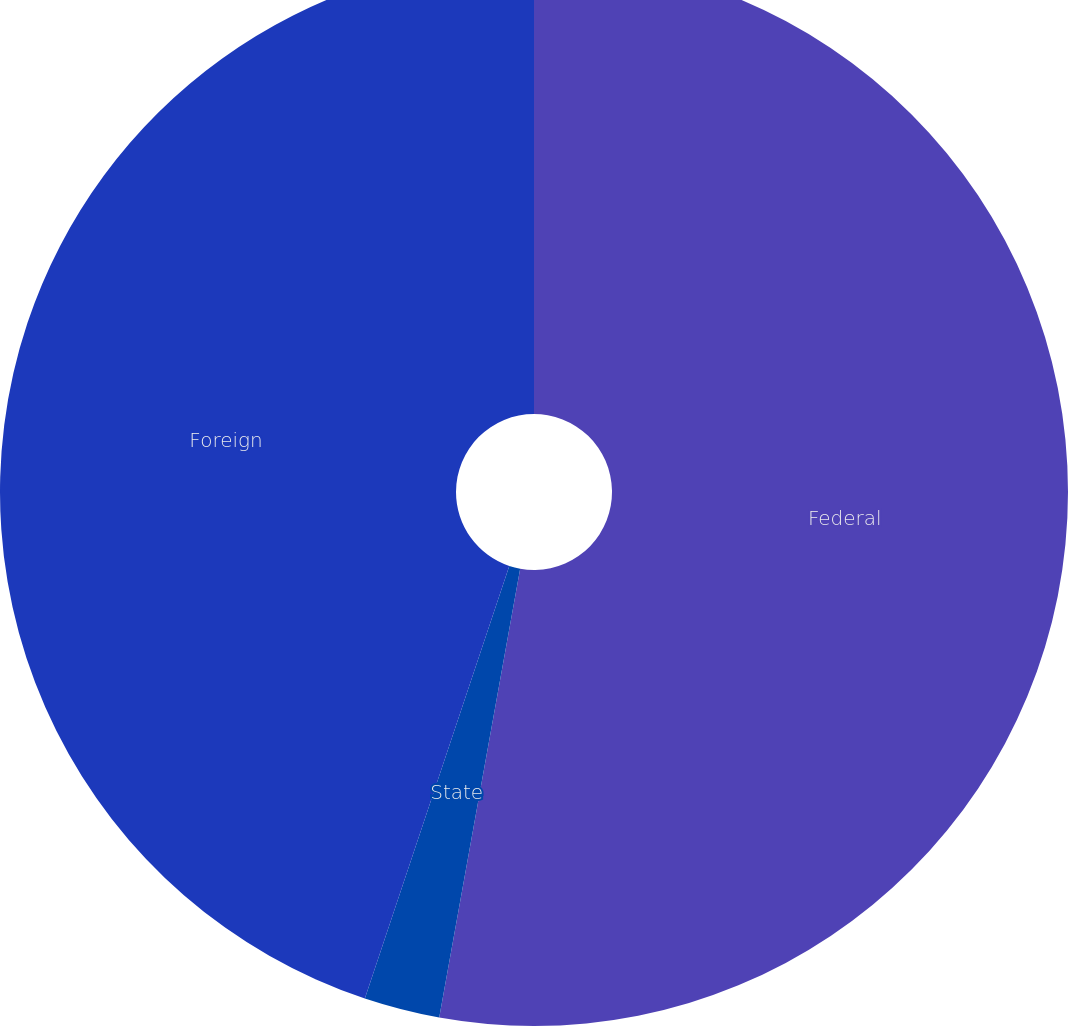Convert chart to OTSL. <chart><loc_0><loc_0><loc_500><loc_500><pie_chart><fcel>Federal<fcel>State<fcel>Foreign<nl><fcel>52.84%<fcel>2.29%<fcel>44.87%<nl></chart> 